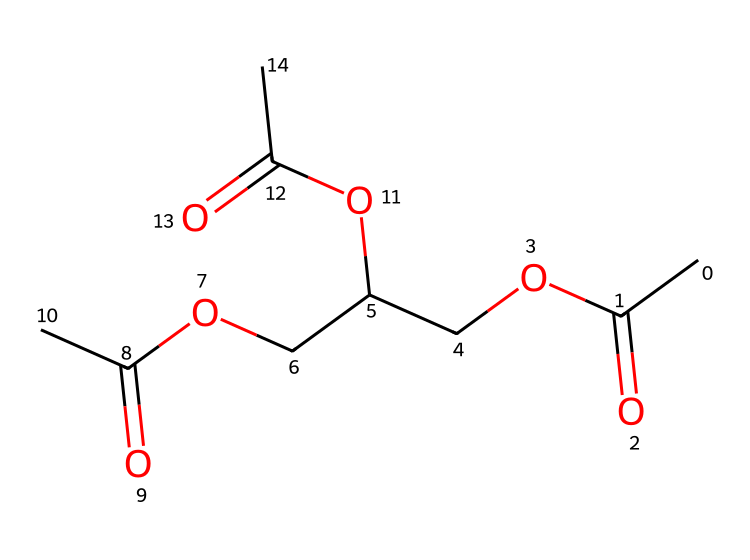How many carbon atoms are in the structure? To determine the number of carbon atoms, count each 'C' in the SMILES representation. Looking carefully, there are a total of 9 carbon atoms present.
Answer: 9 What functional groups are present in this chemical? By analyzing the chemical structure from its SMILES, we can identify ester (–COO–) and carbonyl (C=O) functional groups which are characteristic of esters.
Answer: ester, carbonyl Is this chemical soluble in water? Esters typically have limited solubility in water due to their hydrophobic hydrocarbon chains. However, shorter-chain esters can be more soluble. In this specific molecule, the length indicates low solubility.
Answer: low What kind of reaction produces this ester? This type of ester is usually produced through a reaction called esterification, which involves the reaction of an alcohol and a carboxylic acid.
Answer: esterification Are there any cyclic structures present in this molecule? Examining the structure shows that it comprises linear chains with carbon, hydrogen, and oxygen, without any cycles or rings present. Therefore, there are no cyclic structures.
Answer: no How many ester bonds are formed in this molecule? Counting the ester functional groups in the structure indicates that there are 3 ester bonds formed. This is evident from the arrangement of the –COO– groups between carbon chains.
Answer: 3 